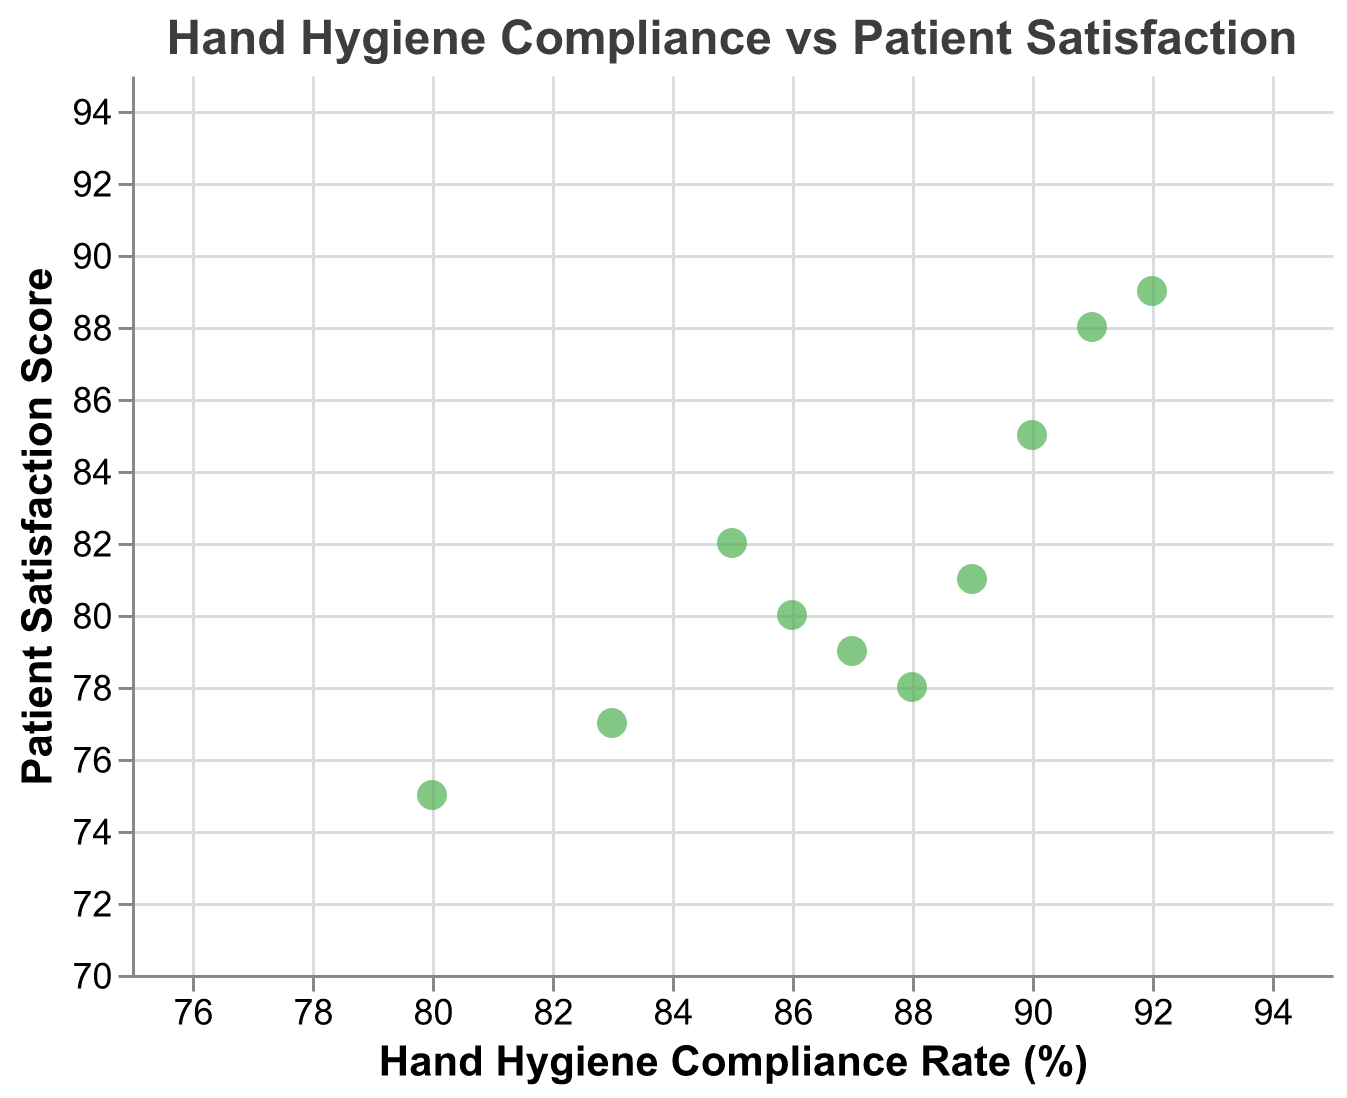How many hospitals are represented in the scatter plot? To find out how many hospitals are represented, count each unique data point in the scatter plot. Each point represents one hospital.
Answer: 10 What is the title of the scatter plot? To identify the title, simply read the text at the top of the scatter plot.
Answer: Hand Hygiene Compliance vs Patient Satisfaction Which hospital has the highest patient satisfaction score? Check the y-axis for the highest point and look at the tooltip to find the corresponding hospital name.
Answer: Riverside Hospital Is there a general trend between hand hygiene compliance rate and patient satisfaction score? Observe the overall distribution and direction of the points. If points generally move upward as you move right, there is a positive trend.
Answer: Yes, a positive trend What is the hand hygiene compliance rate at the hospital with the lowest patient satisfaction score? Identify the point with the lowest y-axis value and read its x-axis value. Also, verify via the tooltip.
Answer: 80 (Coastal Regional Hospital) Compare the patient satisfaction scores of General Hospital and Metro City Hospital. Which one has a higher score? Locate the points for General Hospital and Metro City Hospital in the plot and compare their y-axis values.
Answer: General Hospital Which hospital has a hand hygiene compliance rate of 89%? Locate the point corresponding to 89 on the x-axis and use the tooltip to identify the hospital name.
Answer: Downtown Medical Center Calculate the average hand hygiene compliance rate of all hospitals represented. Add up all the hand hygiene compliance rates and divide by the number of hospitals (10). 
(90 + 88 + 85 + 92 + 86 + 80 + 91 + 83 + 87 + 89) / 10 = 871 / 10
Answer: 87.1 Are there any hospitals with a hand hygiene compliance rate below 85%? If so, which ones? Identify points with x-axis values less than 85 and use the tooltips to find the corresponding hospitals.
Answer: Coastal Regional Hospital, Lakeside Clinic What is the difference in patient satisfaction score between Community Health Clinic and Suburban Health Facility? Find the y-axis values for Community Health Clinic and Suburban Health Facility, then calculate the difference (82 - 79).
Answer: 3 